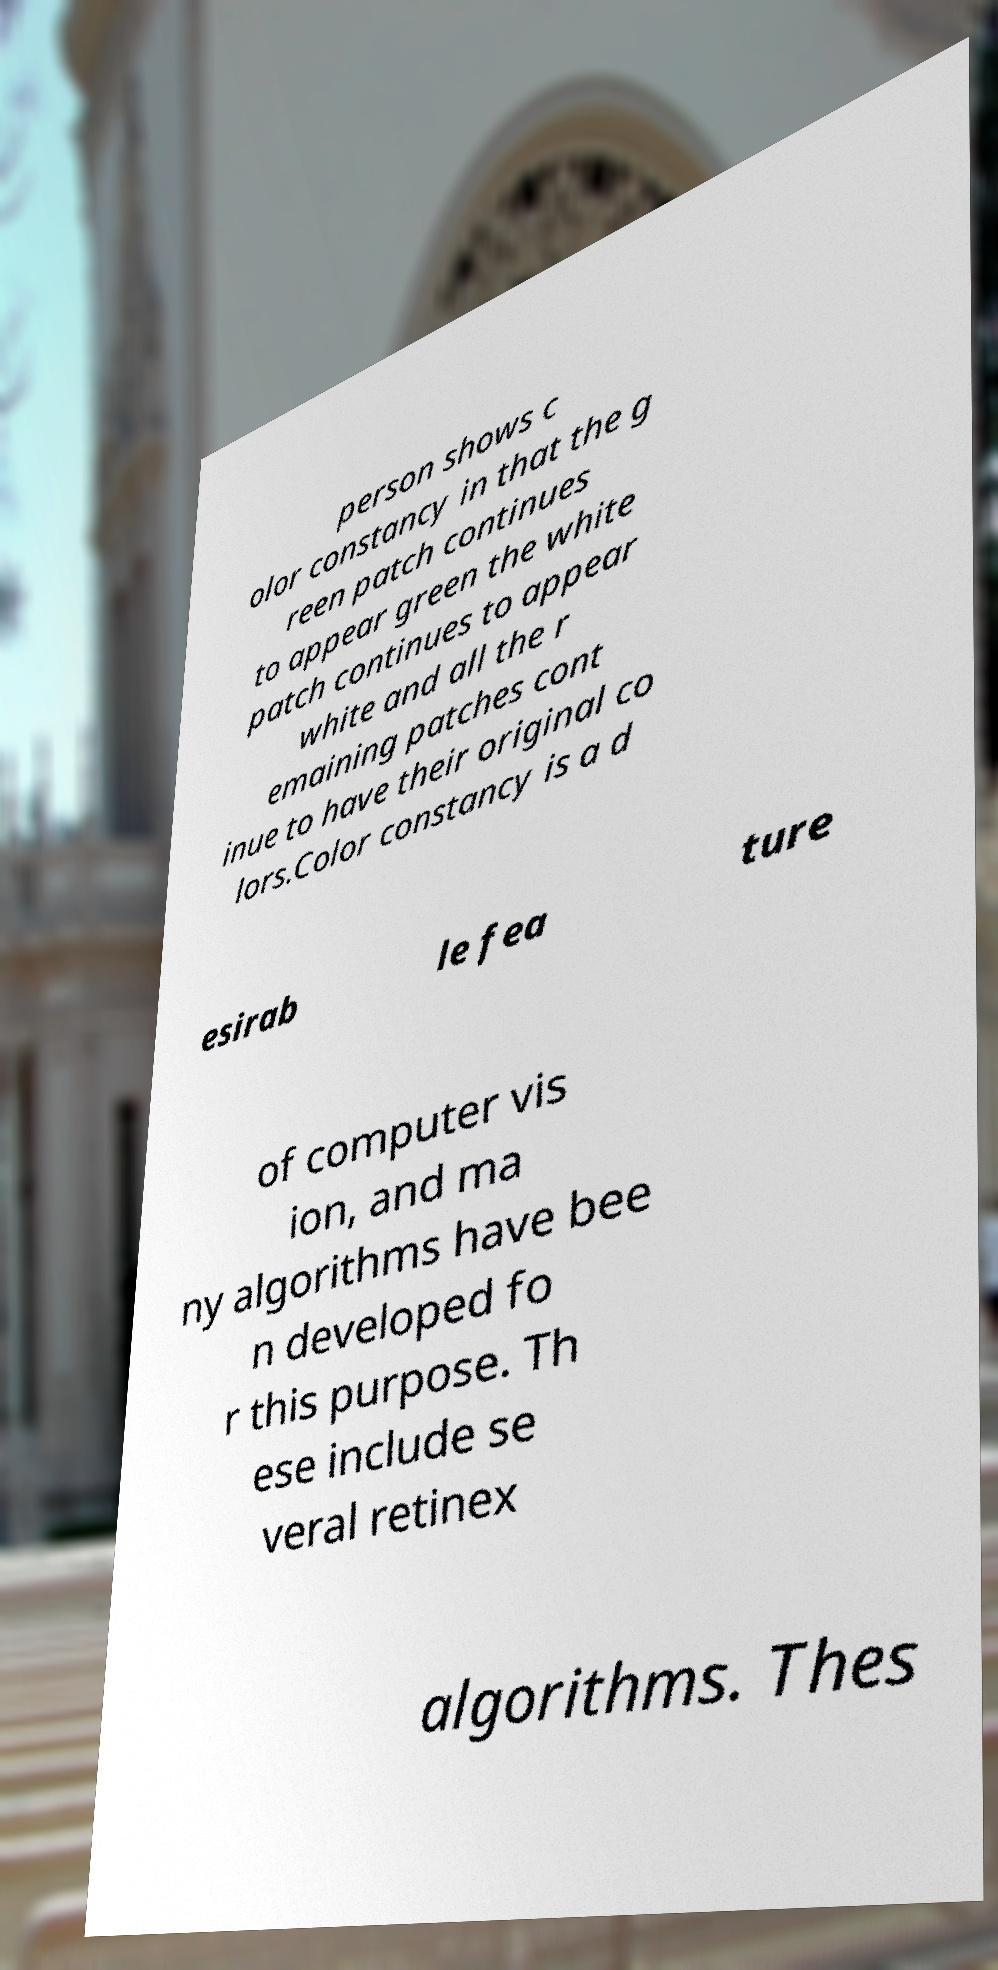Can you read and provide the text displayed in the image?This photo seems to have some interesting text. Can you extract and type it out for me? person shows c olor constancy in that the g reen patch continues to appear green the white patch continues to appear white and all the r emaining patches cont inue to have their original co lors.Color constancy is a d esirab le fea ture of computer vis ion, and ma ny algorithms have bee n developed fo r this purpose. Th ese include se veral retinex algorithms. Thes 